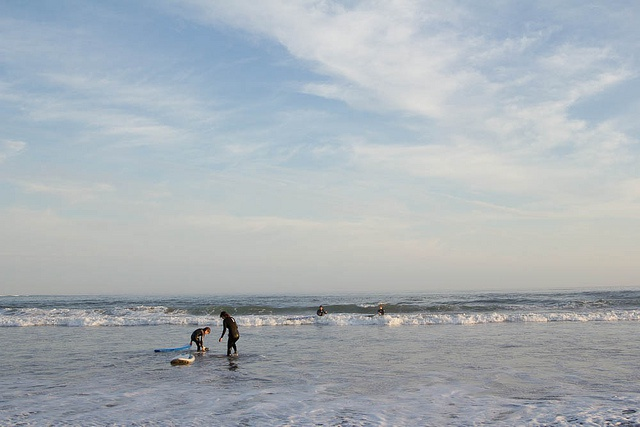Describe the objects in this image and their specific colors. I can see people in darkgray, black, and gray tones, people in darkgray, black, gray, and maroon tones, surfboard in darkgray, gray, and black tones, surfboard in darkgray, black, tan, maroon, and gray tones, and surfboard in darkgray, teal, and gray tones in this image. 